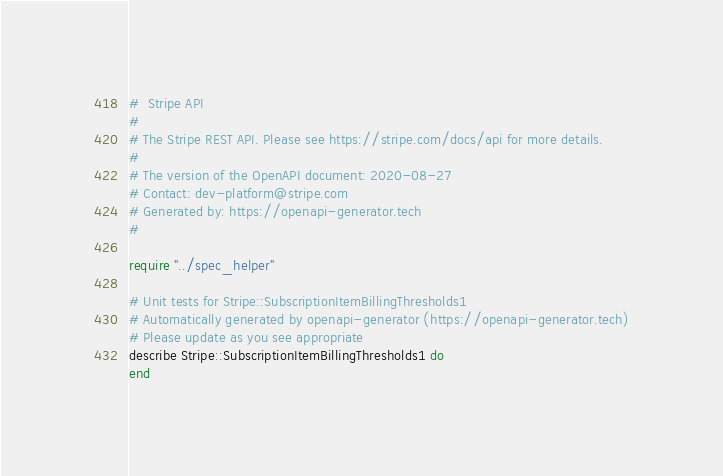<code> <loc_0><loc_0><loc_500><loc_500><_Crystal_>#  Stripe API
#
# The Stripe REST API. Please see https://stripe.com/docs/api for more details.
#
# The version of the OpenAPI document: 2020-08-27
# Contact: dev-platform@stripe.com
# Generated by: https://openapi-generator.tech
#

require "../spec_helper"

# Unit tests for Stripe::SubscriptionItemBillingThresholds1
# Automatically generated by openapi-generator (https://openapi-generator.tech)
# Please update as you see appropriate
describe Stripe::SubscriptionItemBillingThresholds1 do
end
</code> 